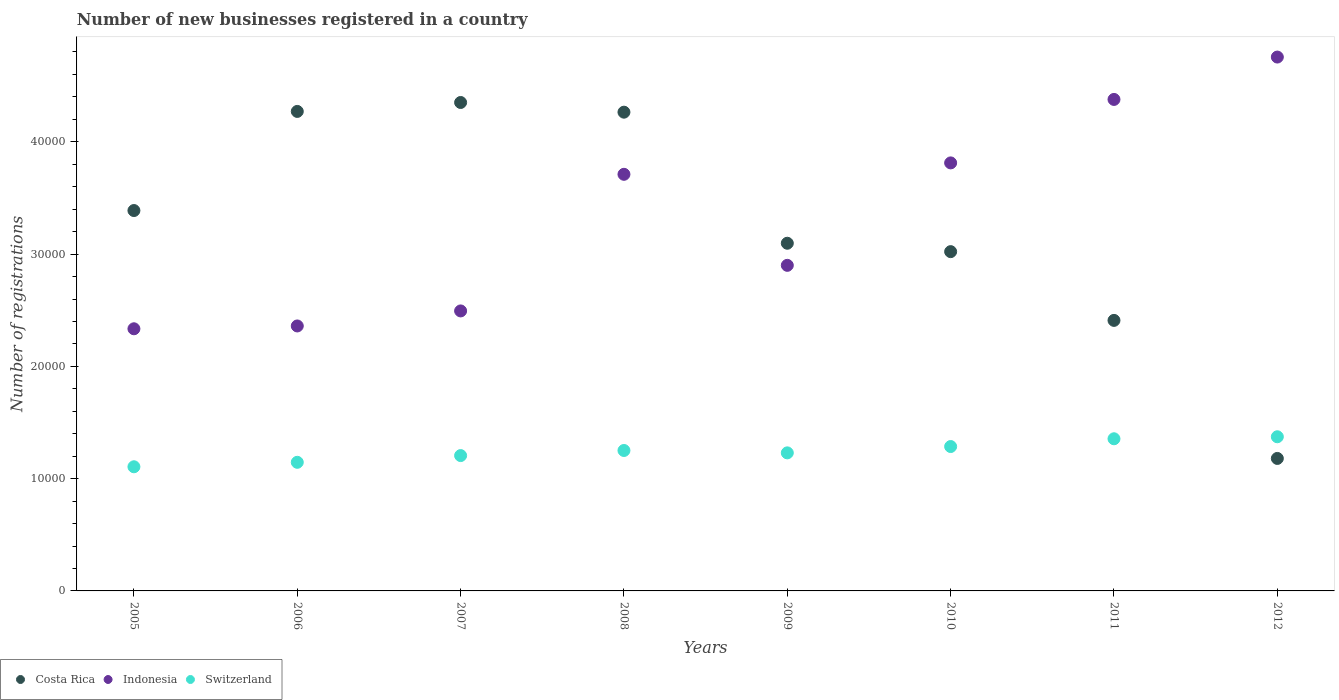How many different coloured dotlines are there?
Your response must be concise. 3. Is the number of dotlines equal to the number of legend labels?
Your response must be concise. Yes. What is the number of new businesses registered in Switzerland in 2008?
Your response must be concise. 1.25e+04. Across all years, what is the maximum number of new businesses registered in Costa Rica?
Offer a very short reply. 4.35e+04. Across all years, what is the minimum number of new businesses registered in Indonesia?
Your answer should be compact. 2.33e+04. In which year was the number of new businesses registered in Indonesia minimum?
Provide a short and direct response. 2005. What is the total number of new businesses registered in Switzerland in the graph?
Offer a very short reply. 9.95e+04. What is the difference between the number of new businesses registered in Indonesia in 2006 and that in 2012?
Offer a very short reply. -2.40e+04. What is the difference between the number of new businesses registered in Costa Rica in 2011 and the number of new businesses registered in Indonesia in 2010?
Provide a short and direct response. -1.40e+04. What is the average number of new businesses registered in Switzerland per year?
Offer a very short reply. 1.24e+04. In the year 2007, what is the difference between the number of new businesses registered in Indonesia and number of new businesses registered in Costa Rica?
Provide a short and direct response. -1.86e+04. What is the ratio of the number of new businesses registered in Indonesia in 2005 to that in 2007?
Give a very brief answer. 0.94. Is the number of new businesses registered in Costa Rica in 2006 less than that in 2012?
Provide a short and direct response. No. Is the difference between the number of new businesses registered in Indonesia in 2011 and 2012 greater than the difference between the number of new businesses registered in Costa Rica in 2011 and 2012?
Provide a succinct answer. No. What is the difference between the highest and the second highest number of new businesses registered in Indonesia?
Your answer should be very brief. 3774. What is the difference between the highest and the lowest number of new businesses registered in Switzerland?
Provide a short and direct response. 2672. In how many years, is the number of new businesses registered in Switzerland greater than the average number of new businesses registered in Switzerland taken over all years?
Make the answer very short. 4. Is the sum of the number of new businesses registered in Indonesia in 2005 and 2007 greater than the maximum number of new businesses registered in Costa Rica across all years?
Your answer should be very brief. Yes. Is it the case that in every year, the sum of the number of new businesses registered in Indonesia and number of new businesses registered in Costa Rica  is greater than the number of new businesses registered in Switzerland?
Ensure brevity in your answer.  Yes. Does the number of new businesses registered in Indonesia monotonically increase over the years?
Give a very brief answer. No. Is the number of new businesses registered in Costa Rica strictly greater than the number of new businesses registered in Indonesia over the years?
Your answer should be very brief. No. Is the number of new businesses registered in Indonesia strictly less than the number of new businesses registered in Costa Rica over the years?
Keep it short and to the point. No. How many years are there in the graph?
Your answer should be compact. 8. What is the difference between two consecutive major ticks on the Y-axis?
Give a very brief answer. 10000. How many legend labels are there?
Offer a very short reply. 3. How are the legend labels stacked?
Give a very brief answer. Horizontal. What is the title of the graph?
Give a very brief answer. Number of new businesses registered in a country. What is the label or title of the X-axis?
Offer a terse response. Years. What is the label or title of the Y-axis?
Your answer should be very brief. Number of registrations. What is the Number of registrations of Costa Rica in 2005?
Provide a short and direct response. 3.39e+04. What is the Number of registrations in Indonesia in 2005?
Your answer should be very brief. 2.33e+04. What is the Number of registrations in Switzerland in 2005?
Offer a very short reply. 1.11e+04. What is the Number of registrations in Costa Rica in 2006?
Make the answer very short. 4.27e+04. What is the Number of registrations in Indonesia in 2006?
Provide a short and direct response. 2.36e+04. What is the Number of registrations of Switzerland in 2006?
Offer a terse response. 1.15e+04. What is the Number of registrations of Costa Rica in 2007?
Your response must be concise. 4.35e+04. What is the Number of registrations in Indonesia in 2007?
Keep it short and to the point. 2.49e+04. What is the Number of registrations in Switzerland in 2007?
Provide a succinct answer. 1.21e+04. What is the Number of registrations of Costa Rica in 2008?
Keep it short and to the point. 4.26e+04. What is the Number of registrations of Indonesia in 2008?
Your answer should be compact. 3.71e+04. What is the Number of registrations of Switzerland in 2008?
Your answer should be compact. 1.25e+04. What is the Number of registrations of Costa Rica in 2009?
Provide a short and direct response. 3.10e+04. What is the Number of registrations in Indonesia in 2009?
Offer a terse response. 2.90e+04. What is the Number of registrations in Switzerland in 2009?
Provide a succinct answer. 1.23e+04. What is the Number of registrations in Costa Rica in 2010?
Keep it short and to the point. 3.02e+04. What is the Number of registrations in Indonesia in 2010?
Your response must be concise. 3.81e+04. What is the Number of registrations of Switzerland in 2010?
Offer a very short reply. 1.29e+04. What is the Number of registrations in Costa Rica in 2011?
Your response must be concise. 2.41e+04. What is the Number of registrations of Indonesia in 2011?
Give a very brief answer. 4.38e+04. What is the Number of registrations of Switzerland in 2011?
Provide a succinct answer. 1.36e+04. What is the Number of registrations in Costa Rica in 2012?
Offer a very short reply. 1.18e+04. What is the Number of registrations in Indonesia in 2012?
Ensure brevity in your answer.  4.75e+04. What is the Number of registrations of Switzerland in 2012?
Offer a terse response. 1.37e+04. Across all years, what is the maximum Number of registrations in Costa Rica?
Your response must be concise. 4.35e+04. Across all years, what is the maximum Number of registrations of Indonesia?
Give a very brief answer. 4.75e+04. Across all years, what is the maximum Number of registrations of Switzerland?
Offer a terse response. 1.37e+04. Across all years, what is the minimum Number of registrations of Costa Rica?
Keep it short and to the point. 1.18e+04. Across all years, what is the minimum Number of registrations in Indonesia?
Your answer should be very brief. 2.33e+04. Across all years, what is the minimum Number of registrations of Switzerland?
Keep it short and to the point. 1.11e+04. What is the total Number of registrations in Costa Rica in the graph?
Keep it short and to the point. 2.60e+05. What is the total Number of registrations in Indonesia in the graph?
Make the answer very short. 2.67e+05. What is the total Number of registrations in Switzerland in the graph?
Make the answer very short. 9.95e+04. What is the difference between the Number of registrations of Costa Rica in 2005 and that in 2006?
Offer a terse response. -8828. What is the difference between the Number of registrations in Indonesia in 2005 and that in 2006?
Provide a short and direct response. -251. What is the difference between the Number of registrations in Switzerland in 2005 and that in 2006?
Provide a short and direct response. -397. What is the difference between the Number of registrations in Costa Rica in 2005 and that in 2007?
Provide a short and direct response. -9624. What is the difference between the Number of registrations in Indonesia in 2005 and that in 2007?
Offer a terse response. -1590. What is the difference between the Number of registrations in Switzerland in 2005 and that in 2007?
Ensure brevity in your answer.  -996. What is the difference between the Number of registrations of Costa Rica in 2005 and that in 2008?
Keep it short and to the point. -8761. What is the difference between the Number of registrations in Indonesia in 2005 and that in 2008?
Your response must be concise. -1.38e+04. What is the difference between the Number of registrations in Switzerland in 2005 and that in 2008?
Provide a short and direct response. -1450. What is the difference between the Number of registrations of Costa Rica in 2005 and that in 2009?
Offer a very short reply. 2913. What is the difference between the Number of registrations of Indonesia in 2005 and that in 2009?
Your answer should be compact. -5650. What is the difference between the Number of registrations in Switzerland in 2005 and that in 2009?
Make the answer very short. -1238. What is the difference between the Number of registrations of Costa Rica in 2005 and that in 2010?
Make the answer very short. 3661. What is the difference between the Number of registrations of Indonesia in 2005 and that in 2010?
Ensure brevity in your answer.  -1.48e+04. What is the difference between the Number of registrations in Switzerland in 2005 and that in 2010?
Offer a terse response. -1802. What is the difference between the Number of registrations of Costa Rica in 2005 and that in 2011?
Keep it short and to the point. 9784. What is the difference between the Number of registrations of Indonesia in 2005 and that in 2011?
Your answer should be very brief. -2.04e+04. What is the difference between the Number of registrations of Switzerland in 2005 and that in 2011?
Keep it short and to the point. -2493. What is the difference between the Number of registrations of Costa Rica in 2005 and that in 2012?
Give a very brief answer. 2.21e+04. What is the difference between the Number of registrations of Indonesia in 2005 and that in 2012?
Provide a short and direct response. -2.42e+04. What is the difference between the Number of registrations in Switzerland in 2005 and that in 2012?
Give a very brief answer. -2672. What is the difference between the Number of registrations in Costa Rica in 2006 and that in 2007?
Provide a short and direct response. -796. What is the difference between the Number of registrations of Indonesia in 2006 and that in 2007?
Offer a very short reply. -1339. What is the difference between the Number of registrations in Switzerland in 2006 and that in 2007?
Offer a very short reply. -599. What is the difference between the Number of registrations in Indonesia in 2006 and that in 2008?
Make the answer very short. -1.35e+04. What is the difference between the Number of registrations of Switzerland in 2006 and that in 2008?
Provide a succinct answer. -1053. What is the difference between the Number of registrations in Costa Rica in 2006 and that in 2009?
Make the answer very short. 1.17e+04. What is the difference between the Number of registrations of Indonesia in 2006 and that in 2009?
Make the answer very short. -5399. What is the difference between the Number of registrations of Switzerland in 2006 and that in 2009?
Provide a succinct answer. -841. What is the difference between the Number of registrations of Costa Rica in 2006 and that in 2010?
Keep it short and to the point. 1.25e+04. What is the difference between the Number of registrations of Indonesia in 2006 and that in 2010?
Give a very brief answer. -1.45e+04. What is the difference between the Number of registrations of Switzerland in 2006 and that in 2010?
Your answer should be compact. -1405. What is the difference between the Number of registrations in Costa Rica in 2006 and that in 2011?
Your answer should be compact. 1.86e+04. What is the difference between the Number of registrations in Indonesia in 2006 and that in 2011?
Provide a short and direct response. -2.02e+04. What is the difference between the Number of registrations in Switzerland in 2006 and that in 2011?
Make the answer very short. -2096. What is the difference between the Number of registrations in Costa Rica in 2006 and that in 2012?
Provide a short and direct response. 3.09e+04. What is the difference between the Number of registrations of Indonesia in 2006 and that in 2012?
Give a very brief answer. -2.40e+04. What is the difference between the Number of registrations of Switzerland in 2006 and that in 2012?
Make the answer very short. -2275. What is the difference between the Number of registrations in Costa Rica in 2007 and that in 2008?
Offer a very short reply. 863. What is the difference between the Number of registrations of Indonesia in 2007 and that in 2008?
Give a very brief answer. -1.22e+04. What is the difference between the Number of registrations in Switzerland in 2007 and that in 2008?
Your answer should be very brief. -454. What is the difference between the Number of registrations in Costa Rica in 2007 and that in 2009?
Your answer should be very brief. 1.25e+04. What is the difference between the Number of registrations of Indonesia in 2007 and that in 2009?
Provide a short and direct response. -4060. What is the difference between the Number of registrations in Switzerland in 2007 and that in 2009?
Your response must be concise. -242. What is the difference between the Number of registrations of Costa Rica in 2007 and that in 2010?
Keep it short and to the point. 1.33e+04. What is the difference between the Number of registrations of Indonesia in 2007 and that in 2010?
Offer a terse response. -1.32e+04. What is the difference between the Number of registrations in Switzerland in 2007 and that in 2010?
Your answer should be compact. -806. What is the difference between the Number of registrations of Costa Rica in 2007 and that in 2011?
Your answer should be very brief. 1.94e+04. What is the difference between the Number of registrations in Indonesia in 2007 and that in 2011?
Make the answer very short. -1.88e+04. What is the difference between the Number of registrations in Switzerland in 2007 and that in 2011?
Keep it short and to the point. -1497. What is the difference between the Number of registrations in Costa Rica in 2007 and that in 2012?
Your answer should be very brief. 3.17e+04. What is the difference between the Number of registrations in Indonesia in 2007 and that in 2012?
Offer a terse response. -2.26e+04. What is the difference between the Number of registrations in Switzerland in 2007 and that in 2012?
Ensure brevity in your answer.  -1676. What is the difference between the Number of registrations in Costa Rica in 2008 and that in 2009?
Your answer should be compact. 1.17e+04. What is the difference between the Number of registrations in Indonesia in 2008 and that in 2009?
Offer a very short reply. 8108. What is the difference between the Number of registrations in Switzerland in 2008 and that in 2009?
Provide a short and direct response. 212. What is the difference between the Number of registrations in Costa Rica in 2008 and that in 2010?
Keep it short and to the point. 1.24e+04. What is the difference between the Number of registrations in Indonesia in 2008 and that in 2010?
Make the answer very short. -1016. What is the difference between the Number of registrations of Switzerland in 2008 and that in 2010?
Give a very brief answer. -352. What is the difference between the Number of registrations of Costa Rica in 2008 and that in 2011?
Give a very brief answer. 1.85e+04. What is the difference between the Number of registrations of Indonesia in 2008 and that in 2011?
Your answer should be very brief. -6669. What is the difference between the Number of registrations of Switzerland in 2008 and that in 2011?
Keep it short and to the point. -1043. What is the difference between the Number of registrations of Costa Rica in 2008 and that in 2012?
Your response must be concise. 3.08e+04. What is the difference between the Number of registrations in Indonesia in 2008 and that in 2012?
Your response must be concise. -1.04e+04. What is the difference between the Number of registrations of Switzerland in 2008 and that in 2012?
Offer a very short reply. -1222. What is the difference between the Number of registrations in Costa Rica in 2009 and that in 2010?
Your answer should be compact. 748. What is the difference between the Number of registrations in Indonesia in 2009 and that in 2010?
Your answer should be compact. -9124. What is the difference between the Number of registrations in Switzerland in 2009 and that in 2010?
Ensure brevity in your answer.  -564. What is the difference between the Number of registrations in Costa Rica in 2009 and that in 2011?
Provide a short and direct response. 6871. What is the difference between the Number of registrations in Indonesia in 2009 and that in 2011?
Make the answer very short. -1.48e+04. What is the difference between the Number of registrations of Switzerland in 2009 and that in 2011?
Provide a succinct answer. -1255. What is the difference between the Number of registrations in Costa Rica in 2009 and that in 2012?
Offer a very short reply. 1.92e+04. What is the difference between the Number of registrations of Indonesia in 2009 and that in 2012?
Offer a terse response. -1.86e+04. What is the difference between the Number of registrations in Switzerland in 2009 and that in 2012?
Make the answer very short. -1434. What is the difference between the Number of registrations in Costa Rica in 2010 and that in 2011?
Ensure brevity in your answer.  6123. What is the difference between the Number of registrations of Indonesia in 2010 and that in 2011?
Keep it short and to the point. -5653. What is the difference between the Number of registrations of Switzerland in 2010 and that in 2011?
Keep it short and to the point. -691. What is the difference between the Number of registrations in Costa Rica in 2010 and that in 2012?
Keep it short and to the point. 1.84e+04. What is the difference between the Number of registrations of Indonesia in 2010 and that in 2012?
Keep it short and to the point. -9427. What is the difference between the Number of registrations in Switzerland in 2010 and that in 2012?
Provide a short and direct response. -870. What is the difference between the Number of registrations of Costa Rica in 2011 and that in 2012?
Provide a succinct answer. 1.23e+04. What is the difference between the Number of registrations of Indonesia in 2011 and that in 2012?
Offer a terse response. -3774. What is the difference between the Number of registrations of Switzerland in 2011 and that in 2012?
Your answer should be very brief. -179. What is the difference between the Number of registrations in Costa Rica in 2005 and the Number of registrations in Indonesia in 2006?
Your answer should be very brief. 1.03e+04. What is the difference between the Number of registrations in Costa Rica in 2005 and the Number of registrations in Switzerland in 2006?
Provide a short and direct response. 2.24e+04. What is the difference between the Number of registrations in Indonesia in 2005 and the Number of registrations in Switzerland in 2006?
Offer a very short reply. 1.19e+04. What is the difference between the Number of registrations of Costa Rica in 2005 and the Number of registrations of Indonesia in 2007?
Provide a short and direct response. 8941. What is the difference between the Number of registrations in Costa Rica in 2005 and the Number of registrations in Switzerland in 2007?
Your answer should be compact. 2.18e+04. What is the difference between the Number of registrations of Indonesia in 2005 and the Number of registrations of Switzerland in 2007?
Your answer should be compact. 1.13e+04. What is the difference between the Number of registrations in Costa Rica in 2005 and the Number of registrations in Indonesia in 2008?
Your response must be concise. -3227. What is the difference between the Number of registrations of Costa Rica in 2005 and the Number of registrations of Switzerland in 2008?
Ensure brevity in your answer.  2.14e+04. What is the difference between the Number of registrations in Indonesia in 2005 and the Number of registrations in Switzerland in 2008?
Offer a terse response. 1.08e+04. What is the difference between the Number of registrations in Costa Rica in 2005 and the Number of registrations in Indonesia in 2009?
Ensure brevity in your answer.  4881. What is the difference between the Number of registrations in Costa Rica in 2005 and the Number of registrations in Switzerland in 2009?
Give a very brief answer. 2.16e+04. What is the difference between the Number of registrations in Indonesia in 2005 and the Number of registrations in Switzerland in 2009?
Your answer should be very brief. 1.11e+04. What is the difference between the Number of registrations of Costa Rica in 2005 and the Number of registrations of Indonesia in 2010?
Make the answer very short. -4243. What is the difference between the Number of registrations of Costa Rica in 2005 and the Number of registrations of Switzerland in 2010?
Give a very brief answer. 2.10e+04. What is the difference between the Number of registrations of Indonesia in 2005 and the Number of registrations of Switzerland in 2010?
Provide a short and direct response. 1.05e+04. What is the difference between the Number of registrations in Costa Rica in 2005 and the Number of registrations in Indonesia in 2011?
Offer a terse response. -9896. What is the difference between the Number of registrations in Costa Rica in 2005 and the Number of registrations in Switzerland in 2011?
Your response must be concise. 2.03e+04. What is the difference between the Number of registrations of Indonesia in 2005 and the Number of registrations of Switzerland in 2011?
Ensure brevity in your answer.  9797. What is the difference between the Number of registrations of Costa Rica in 2005 and the Number of registrations of Indonesia in 2012?
Keep it short and to the point. -1.37e+04. What is the difference between the Number of registrations of Costa Rica in 2005 and the Number of registrations of Switzerland in 2012?
Offer a very short reply. 2.01e+04. What is the difference between the Number of registrations of Indonesia in 2005 and the Number of registrations of Switzerland in 2012?
Your response must be concise. 9618. What is the difference between the Number of registrations of Costa Rica in 2006 and the Number of registrations of Indonesia in 2007?
Your response must be concise. 1.78e+04. What is the difference between the Number of registrations in Costa Rica in 2006 and the Number of registrations in Switzerland in 2007?
Provide a short and direct response. 3.07e+04. What is the difference between the Number of registrations in Indonesia in 2006 and the Number of registrations in Switzerland in 2007?
Make the answer very short. 1.15e+04. What is the difference between the Number of registrations of Costa Rica in 2006 and the Number of registrations of Indonesia in 2008?
Provide a short and direct response. 5601. What is the difference between the Number of registrations of Costa Rica in 2006 and the Number of registrations of Switzerland in 2008?
Offer a terse response. 3.02e+04. What is the difference between the Number of registrations of Indonesia in 2006 and the Number of registrations of Switzerland in 2008?
Your answer should be very brief. 1.11e+04. What is the difference between the Number of registrations of Costa Rica in 2006 and the Number of registrations of Indonesia in 2009?
Provide a short and direct response. 1.37e+04. What is the difference between the Number of registrations in Costa Rica in 2006 and the Number of registrations in Switzerland in 2009?
Your answer should be very brief. 3.04e+04. What is the difference between the Number of registrations of Indonesia in 2006 and the Number of registrations of Switzerland in 2009?
Give a very brief answer. 1.13e+04. What is the difference between the Number of registrations of Costa Rica in 2006 and the Number of registrations of Indonesia in 2010?
Provide a short and direct response. 4585. What is the difference between the Number of registrations of Costa Rica in 2006 and the Number of registrations of Switzerland in 2010?
Make the answer very short. 2.98e+04. What is the difference between the Number of registrations of Indonesia in 2006 and the Number of registrations of Switzerland in 2010?
Offer a very short reply. 1.07e+04. What is the difference between the Number of registrations of Costa Rica in 2006 and the Number of registrations of Indonesia in 2011?
Provide a short and direct response. -1068. What is the difference between the Number of registrations in Costa Rica in 2006 and the Number of registrations in Switzerland in 2011?
Your answer should be compact. 2.92e+04. What is the difference between the Number of registrations of Indonesia in 2006 and the Number of registrations of Switzerland in 2011?
Your response must be concise. 1.00e+04. What is the difference between the Number of registrations of Costa Rica in 2006 and the Number of registrations of Indonesia in 2012?
Ensure brevity in your answer.  -4842. What is the difference between the Number of registrations of Costa Rica in 2006 and the Number of registrations of Switzerland in 2012?
Offer a very short reply. 2.90e+04. What is the difference between the Number of registrations in Indonesia in 2006 and the Number of registrations in Switzerland in 2012?
Provide a short and direct response. 9869. What is the difference between the Number of registrations in Costa Rica in 2007 and the Number of registrations in Indonesia in 2008?
Provide a succinct answer. 6397. What is the difference between the Number of registrations of Costa Rica in 2007 and the Number of registrations of Switzerland in 2008?
Keep it short and to the point. 3.10e+04. What is the difference between the Number of registrations of Indonesia in 2007 and the Number of registrations of Switzerland in 2008?
Ensure brevity in your answer.  1.24e+04. What is the difference between the Number of registrations of Costa Rica in 2007 and the Number of registrations of Indonesia in 2009?
Offer a very short reply. 1.45e+04. What is the difference between the Number of registrations in Costa Rica in 2007 and the Number of registrations in Switzerland in 2009?
Offer a very short reply. 3.12e+04. What is the difference between the Number of registrations of Indonesia in 2007 and the Number of registrations of Switzerland in 2009?
Your response must be concise. 1.26e+04. What is the difference between the Number of registrations in Costa Rica in 2007 and the Number of registrations in Indonesia in 2010?
Keep it short and to the point. 5381. What is the difference between the Number of registrations of Costa Rica in 2007 and the Number of registrations of Switzerland in 2010?
Provide a succinct answer. 3.06e+04. What is the difference between the Number of registrations in Indonesia in 2007 and the Number of registrations in Switzerland in 2010?
Your answer should be very brief. 1.21e+04. What is the difference between the Number of registrations of Costa Rica in 2007 and the Number of registrations of Indonesia in 2011?
Keep it short and to the point. -272. What is the difference between the Number of registrations of Costa Rica in 2007 and the Number of registrations of Switzerland in 2011?
Make the answer very short. 3.00e+04. What is the difference between the Number of registrations in Indonesia in 2007 and the Number of registrations in Switzerland in 2011?
Provide a succinct answer. 1.14e+04. What is the difference between the Number of registrations in Costa Rica in 2007 and the Number of registrations in Indonesia in 2012?
Offer a terse response. -4046. What is the difference between the Number of registrations of Costa Rica in 2007 and the Number of registrations of Switzerland in 2012?
Your response must be concise. 2.98e+04. What is the difference between the Number of registrations of Indonesia in 2007 and the Number of registrations of Switzerland in 2012?
Provide a short and direct response. 1.12e+04. What is the difference between the Number of registrations of Costa Rica in 2008 and the Number of registrations of Indonesia in 2009?
Ensure brevity in your answer.  1.36e+04. What is the difference between the Number of registrations in Costa Rica in 2008 and the Number of registrations in Switzerland in 2009?
Make the answer very short. 3.03e+04. What is the difference between the Number of registrations of Indonesia in 2008 and the Number of registrations of Switzerland in 2009?
Provide a succinct answer. 2.48e+04. What is the difference between the Number of registrations of Costa Rica in 2008 and the Number of registrations of Indonesia in 2010?
Provide a short and direct response. 4518. What is the difference between the Number of registrations in Costa Rica in 2008 and the Number of registrations in Switzerland in 2010?
Keep it short and to the point. 2.98e+04. What is the difference between the Number of registrations of Indonesia in 2008 and the Number of registrations of Switzerland in 2010?
Ensure brevity in your answer.  2.42e+04. What is the difference between the Number of registrations of Costa Rica in 2008 and the Number of registrations of Indonesia in 2011?
Give a very brief answer. -1135. What is the difference between the Number of registrations in Costa Rica in 2008 and the Number of registrations in Switzerland in 2011?
Ensure brevity in your answer.  2.91e+04. What is the difference between the Number of registrations in Indonesia in 2008 and the Number of registrations in Switzerland in 2011?
Offer a very short reply. 2.36e+04. What is the difference between the Number of registrations of Costa Rica in 2008 and the Number of registrations of Indonesia in 2012?
Keep it short and to the point. -4909. What is the difference between the Number of registrations in Costa Rica in 2008 and the Number of registrations in Switzerland in 2012?
Make the answer very short. 2.89e+04. What is the difference between the Number of registrations of Indonesia in 2008 and the Number of registrations of Switzerland in 2012?
Give a very brief answer. 2.34e+04. What is the difference between the Number of registrations in Costa Rica in 2009 and the Number of registrations in Indonesia in 2010?
Offer a very short reply. -7156. What is the difference between the Number of registrations of Costa Rica in 2009 and the Number of registrations of Switzerland in 2010?
Give a very brief answer. 1.81e+04. What is the difference between the Number of registrations in Indonesia in 2009 and the Number of registrations in Switzerland in 2010?
Offer a terse response. 1.61e+04. What is the difference between the Number of registrations of Costa Rica in 2009 and the Number of registrations of Indonesia in 2011?
Keep it short and to the point. -1.28e+04. What is the difference between the Number of registrations of Costa Rica in 2009 and the Number of registrations of Switzerland in 2011?
Keep it short and to the point. 1.74e+04. What is the difference between the Number of registrations of Indonesia in 2009 and the Number of registrations of Switzerland in 2011?
Your answer should be compact. 1.54e+04. What is the difference between the Number of registrations of Costa Rica in 2009 and the Number of registrations of Indonesia in 2012?
Ensure brevity in your answer.  -1.66e+04. What is the difference between the Number of registrations of Costa Rica in 2009 and the Number of registrations of Switzerland in 2012?
Offer a very short reply. 1.72e+04. What is the difference between the Number of registrations of Indonesia in 2009 and the Number of registrations of Switzerland in 2012?
Keep it short and to the point. 1.53e+04. What is the difference between the Number of registrations of Costa Rica in 2010 and the Number of registrations of Indonesia in 2011?
Your response must be concise. -1.36e+04. What is the difference between the Number of registrations in Costa Rica in 2010 and the Number of registrations in Switzerland in 2011?
Your answer should be very brief. 1.67e+04. What is the difference between the Number of registrations in Indonesia in 2010 and the Number of registrations in Switzerland in 2011?
Provide a short and direct response. 2.46e+04. What is the difference between the Number of registrations of Costa Rica in 2010 and the Number of registrations of Indonesia in 2012?
Keep it short and to the point. -1.73e+04. What is the difference between the Number of registrations of Costa Rica in 2010 and the Number of registrations of Switzerland in 2012?
Ensure brevity in your answer.  1.65e+04. What is the difference between the Number of registrations of Indonesia in 2010 and the Number of registrations of Switzerland in 2012?
Keep it short and to the point. 2.44e+04. What is the difference between the Number of registrations of Costa Rica in 2011 and the Number of registrations of Indonesia in 2012?
Give a very brief answer. -2.35e+04. What is the difference between the Number of registrations of Costa Rica in 2011 and the Number of registrations of Switzerland in 2012?
Your answer should be very brief. 1.04e+04. What is the difference between the Number of registrations in Indonesia in 2011 and the Number of registrations in Switzerland in 2012?
Offer a very short reply. 3.00e+04. What is the average Number of registrations in Costa Rica per year?
Offer a very short reply. 3.25e+04. What is the average Number of registrations of Indonesia per year?
Make the answer very short. 3.34e+04. What is the average Number of registrations in Switzerland per year?
Offer a terse response. 1.24e+04. In the year 2005, what is the difference between the Number of registrations of Costa Rica and Number of registrations of Indonesia?
Your answer should be very brief. 1.05e+04. In the year 2005, what is the difference between the Number of registrations in Costa Rica and Number of registrations in Switzerland?
Make the answer very short. 2.28e+04. In the year 2005, what is the difference between the Number of registrations of Indonesia and Number of registrations of Switzerland?
Offer a terse response. 1.23e+04. In the year 2006, what is the difference between the Number of registrations of Costa Rica and Number of registrations of Indonesia?
Offer a terse response. 1.91e+04. In the year 2006, what is the difference between the Number of registrations in Costa Rica and Number of registrations in Switzerland?
Provide a short and direct response. 3.13e+04. In the year 2006, what is the difference between the Number of registrations in Indonesia and Number of registrations in Switzerland?
Offer a very short reply. 1.21e+04. In the year 2007, what is the difference between the Number of registrations of Costa Rica and Number of registrations of Indonesia?
Make the answer very short. 1.86e+04. In the year 2007, what is the difference between the Number of registrations in Costa Rica and Number of registrations in Switzerland?
Ensure brevity in your answer.  3.14e+04. In the year 2007, what is the difference between the Number of registrations in Indonesia and Number of registrations in Switzerland?
Offer a very short reply. 1.29e+04. In the year 2008, what is the difference between the Number of registrations in Costa Rica and Number of registrations in Indonesia?
Ensure brevity in your answer.  5534. In the year 2008, what is the difference between the Number of registrations of Costa Rica and Number of registrations of Switzerland?
Offer a very short reply. 3.01e+04. In the year 2008, what is the difference between the Number of registrations in Indonesia and Number of registrations in Switzerland?
Offer a very short reply. 2.46e+04. In the year 2009, what is the difference between the Number of registrations in Costa Rica and Number of registrations in Indonesia?
Offer a very short reply. 1968. In the year 2009, what is the difference between the Number of registrations of Costa Rica and Number of registrations of Switzerland?
Offer a very short reply. 1.87e+04. In the year 2009, what is the difference between the Number of registrations in Indonesia and Number of registrations in Switzerland?
Ensure brevity in your answer.  1.67e+04. In the year 2010, what is the difference between the Number of registrations in Costa Rica and Number of registrations in Indonesia?
Ensure brevity in your answer.  -7904. In the year 2010, what is the difference between the Number of registrations of Costa Rica and Number of registrations of Switzerland?
Give a very brief answer. 1.74e+04. In the year 2010, what is the difference between the Number of registrations of Indonesia and Number of registrations of Switzerland?
Offer a very short reply. 2.53e+04. In the year 2011, what is the difference between the Number of registrations in Costa Rica and Number of registrations in Indonesia?
Provide a short and direct response. -1.97e+04. In the year 2011, what is the difference between the Number of registrations in Costa Rica and Number of registrations in Switzerland?
Provide a short and direct response. 1.05e+04. In the year 2011, what is the difference between the Number of registrations of Indonesia and Number of registrations of Switzerland?
Offer a very short reply. 3.02e+04. In the year 2012, what is the difference between the Number of registrations of Costa Rica and Number of registrations of Indonesia?
Provide a succinct answer. -3.57e+04. In the year 2012, what is the difference between the Number of registrations of Costa Rica and Number of registrations of Switzerland?
Give a very brief answer. -1930. In the year 2012, what is the difference between the Number of registrations of Indonesia and Number of registrations of Switzerland?
Your answer should be compact. 3.38e+04. What is the ratio of the Number of registrations in Costa Rica in 2005 to that in 2006?
Provide a succinct answer. 0.79. What is the ratio of the Number of registrations of Indonesia in 2005 to that in 2006?
Offer a terse response. 0.99. What is the ratio of the Number of registrations in Switzerland in 2005 to that in 2006?
Your response must be concise. 0.97. What is the ratio of the Number of registrations in Costa Rica in 2005 to that in 2007?
Offer a very short reply. 0.78. What is the ratio of the Number of registrations in Indonesia in 2005 to that in 2007?
Your response must be concise. 0.94. What is the ratio of the Number of registrations of Switzerland in 2005 to that in 2007?
Provide a short and direct response. 0.92. What is the ratio of the Number of registrations in Costa Rica in 2005 to that in 2008?
Provide a short and direct response. 0.79. What is the ratio of the Number of registrations in Indonesia in 2005 to that in 2008?
Your answer should be compact. 0.63. What is the ratio of the Number of registrations in Switzerland in 2005 to that in 2008?
Provide a short and direct response. 0.88. What is the ratio of the Number of registrations of Costa Rica in 2005 to that in 2009?
Your answer should be compact. 1.09. What is the ratio of the Number of registrations of Indonesia in 2005 to that in 2009?
Your answer should be compact. 0.81. What is the ratio of the Number of registrations of Switzerland in 2005 to that in 2009?
Your answer should be compact. 0.9. What is the ratio of the Number of registrations in Costa Rica in 2005 to that in 2010?
Give a very brief answer. 1.12. What is the ratio of the Number of registrations in Indonesia in 2005 to that in 2010?
Provide a succinct answer. 0.61. What is the ratio of the Number of registrations in Switzerland in 2005 to that in 2010?
Your answer should be very brief. 0.86. What is the ratio of the Number of registrations of Costa Rica in 2005 to that in 2011?
Make the answer very short. 1.41. What is the ratio of the Number of registrations in Indonesia in 2005 to that in 2011?
Provide a short and direct response. 0.53. What is the ratio of the Number of registrations of Switzerland in 2005 to that in 2011?
Give a very brief answer. 0.82. What is the ratio of the Number of registrations in Costa Rica in 2005 to that in 2012?
Give a very brief answer. 2.87. What is the ratio of the Number of registrations in Indonesia in 2005 to that in 2012?
Your response must be concise. 0.49. What is the ratio of the Number of registrations of Switzerland in 2005 to that in 2012?
Make the answer very short. 0.81. What is the ratio of the Number of registrations in Costa Rica in 2006 to that in 2007?
Offer a very short reply. 0.98. What is the ratio of the Number of registrations in Indonesia in 2006 to that in 2007?
Your answer should be compact. 0.95. What is the ratio of the Number of registrations in Switzerland in 2006 to that in 2007?
Ensure brevity in your answer.  0.95. What is the ratio of the Number of registrations of Indonesia in 2006 to that in 2008?
Ensure brevity in your answer.  0.64. What is the ratio of the Number of registrations of Switzerland in 2006 to that in 2008?
Provide a succinct answer. 0.92. What is the ratio of the Number of registrations in Costa Rica in 2006 to that in 2009?
Give a very brief answer. 1.38. What is the ratio of the Number of registrations in Indonesia in 2006 to that in 2009?
Your answer should be compact. 0.81. What is the ratio of the Number of registrations of Switzerland in 2006 to that in 2009?
Your answer should be compact. 0.93. What is the ratio of the Number of registrations in Costa Rica in 2006 to that in 2010?
Make the answer very short. 1.41. What is the ratio of the Number of registrations in Indonesia in 2006 to that in 2010?
Offer a very short reply. 0.62. What is the ratio of the Number of registrations in Switzerland in 2006 to that in 2010?
Ensure brevity in your answer.  0.89. What is the ratio of the Number of registrations in Costa Rica in 2006 to that in 2011?
Give a very brief answer. 1.77. What is the ratio of the Number of registrations of Indonesia in 2006 to that in 2011?
Ensure brevity in your answer.  0.54. What is the ratio of the Number of registrations of Switzerland in 2006 to that in 2011?
Your response must be concise. 0.85. What is the ratio of the Number of registrations of Costa Rica in 2006 to that in 2012?
Your response must be concise. 3.62. What is the ratio of the Number of registrations of Indonesia in 2006 to that in 2012?
Your response must be concise. 0.5. What is the ratio of the Number of registrations in Switzerland in 2006 to that in 2012?
Your answer should be very brief. 0.83. What is the ratio of the Number of registrations of Costa Rica in 2007 to that in 2008?
Provide a succinct answer. 1.02. What is the ratio of the Number of registrations in Indonesia in 2007 to that in 2008?
Offer a very short reply. 0.67. What is the ratio of the Number of registrations of Switzerland in 2007 to that in 2008?
Ensure brevity in your answer.  0.96. What is the ratio of the Number of registrations of Costa Rica in 2007 to that in 2009?
Keep it short and to the point. 1.4. What is the ratio of the Number of registrations in Indonesia in 2007 to that in 2009?
Offer a terse response. 0.86. What is the ratio of the Number of registrations of Switzerland in 2007 to that in 2009?
Offer a terse response. 0.98. What is the ratio of the Number of registrations of Costa Rica in 2007 to that in 2010?
Give a very brief answer. 1.44. What is the ratio of the Number of registrations in Indonesia in 2007 to that in 2010?
Offer a very short reply. 0.65. What is the ratio of the Number of registrations in Switzerland in 2007 to that in 2010?
Make the answer very short. 0.94. What is the ratio of the Number of registrations in Costa Rica in 2007 to that in 2011?
Your answer should be very brief. 1.81. What is the ratio of the Number of registrations in Indonesia in 2007 to that in 2011?
Your answer should be very brief. 0.57. What is the ratio of the Number of registrations in Switzerland in 2007 to that in 2011?
Offer a terse response. 0.89. What is the ratio of the Number of registrations in Costa Rica in 2007 to that in 2012?
Make the answer very short. 3.69. What is the ratio of the Number of registrations in Indonesia in 2007 to that in 2012?
Make the answer very short. 0.52. What is the ratio of the Number of registrations of Switzerland in 2007 to that in 2012?
Give a very brief answer. 0.88. What is the ratio of the Number of registrations of Costa Rica in 2008 to that in 2009?
Ensure brevity in your answer.  1.38. What is the ratio of the Number of registrations of Indonesia in 2008 to that in 2009?
Give a very brief answer. 1.28. What is the ratio of the Number of registrations of Switzerland in 2008 to that in 2009?
Ensure brevity in your answer.  1.02. What is the ratio of the Number of registrations of Costa Rica in 2008 to that in 2010?
Make the answer very short. 1.41. What is the ratio of the Number of registrations in Indonesia in 2008 to that in 2010?
Make the answer very short. 0.97. What is the ratio of the Number of registrations of Switzerland in 2008 to that in 2010?
Provide a succinct answer. 0.97. What is the ratio of the Number of registrations of Costa Rica in 2008 to that in 2011?
Ensure brevity in your answer.  1.77. What is the ratio of the Number of registrations in Indonesia in 2008 to that in 2011?
Provide a succinct answer. 0.85. What is the ratio of the Number of registrations of Switzerland in 2008 to that in 2011?
Provide a short and direct response. 0.92. What is the ratio of the Number of registrations of Costa Rica in 2008 to that in 2012?
Offer a terse response. 3.61. What is the ratio of the Number of registrations of Indonesia in 2008 to that in 2012?
Make the answer very short. 0.78. What is the ratio of the Number of registrations in Switzerland in 2008 to that in 2012?
Your answer should be very brief. 0.91. What is the ratio of the Number of registrations in Costa Rica in 2009 to that in 2010?
Provide a succinct answer. 1.02. What is the ratio of the Number of registrations in Indonesia in 2009 to that in 2010?
Keep it short and to the point. 0.76. What is the ratio of the Number of registrations of Switzerland in 2009 to that in 2010?
Provide a short and direct response. 0.96. What is the ratio of the Number of registrations in Costa Rica in 2009 to that in 2011?
Ensure brevity in your answer.  1.29. What is the ratio of the Number of registrations in Indonesia in 2009 to that in 2011?
Provide a succinct answer. 0.66. What is the ratio of the Number of registrations in Switzerland in 2009 to that in 2011?
Offer a terse response. 0.91. What is the ratio of the Number of registrations in Costa Rica in 2009 to that in 2012?
Provide a succinct answer. 2.62. What is the ratio of the Number of registrations in Indonesia in 2009 to that in 2012?
Provide a short and direct response. 0.61. What is the ratio of the Number of registrations of Switzerland in 2009 to that in 2012?
Keep it short and to the point. 0.9. What is the ratio of the Number of registrations in Costa Rica in 2010 to that in 2011?
Offer a terse response. 1.25. What is the ratio of the Number of registrations in Indonesia in 2010 to that in 2011?
Make the answer very short. 0.87. What is the ratio of the Number of registrations of Switzerland in 2010 to that in 2011?
Keep it short and to the point. 0.95. What is the ratio of the Number of registrations of Costa Rica in 2010 to that in 2012?
Provide a succinct answer. 2.56. What is the ratio of the Number of registrations of Indonesia in 2010 to that in 2012?
Give a very brief answer. 0.8. What is the ratio of the Number of registrations in Switzerland in 2010 to that in 2012?
Your answer should be very brief. 0.94. What is the ratio of the Number of registrations in Costa Rica in 2011 to that in 2012?
Give a very brief answer. 2.04. What is the ratio of the Number of registrations in Indonesia in 2011 to that in 2012?
Offer a very short reply. 0.92. What is the ratio of the Number of registrations of Switzerland in 2011 to that in 2012?
Provide a short and direct response. 0.99. What is the difference between the highest and the second highest Number of registrations of Costa Rica?
Ensure brevity in your answer.  796. What is the difference between the highest and the second highest Number of registrations of Indonesia?
Your response must be concise. 3774. What is the difference between the highest and the second highest Number of registrations of Switzerland?
Provide a succinct answer. 179. What is the difference between the highest and the lowest Number of registrations of Costa Rica?
Keep it short and to the point. 3.17e+04. What is the difference between the highest and the lowest Number of registrations in Indonesia?
Your answer should be compact. 2.42e+04. What is the difference between the highest and the lowest Number of registrations of Switzerland?
Offer a very short reply. 2672. 